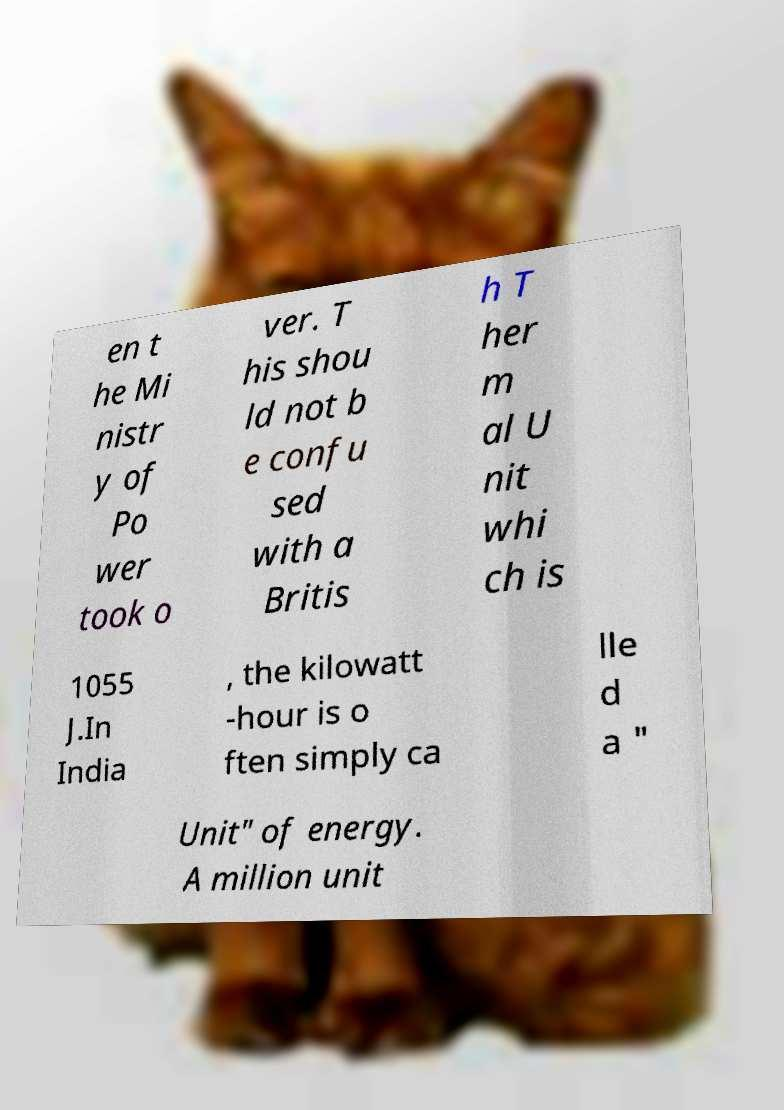What messages or text are displayed in this image? I need them in a readable, typed format. en t he Mi nistr y of Po wer took o ver. T his shou ld not b e confu sed with a Britis h T her m al U nit whi ch is 1055 J.In India , the kilowatt -hour is o ften simply ca lle d a " Unit" of energy. A million unit 